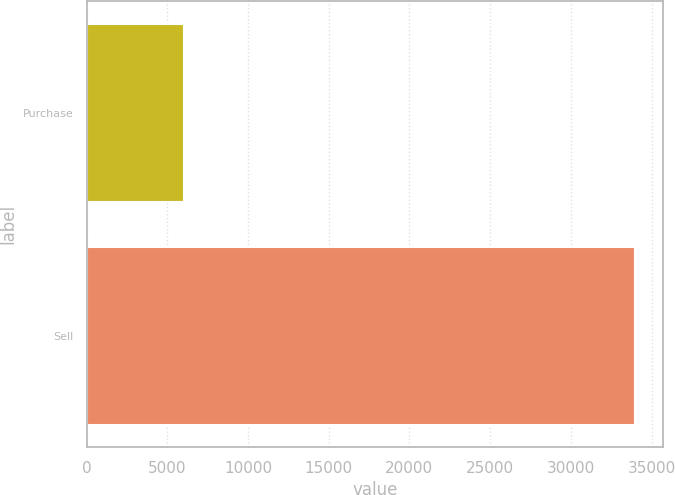<chart> <loc_0><loc_0><loc_500><loc_500><bar_chart><fcel>Purchase<fcel>Sell<nl><fcel>6066<fcel>33999<nl></chart> 